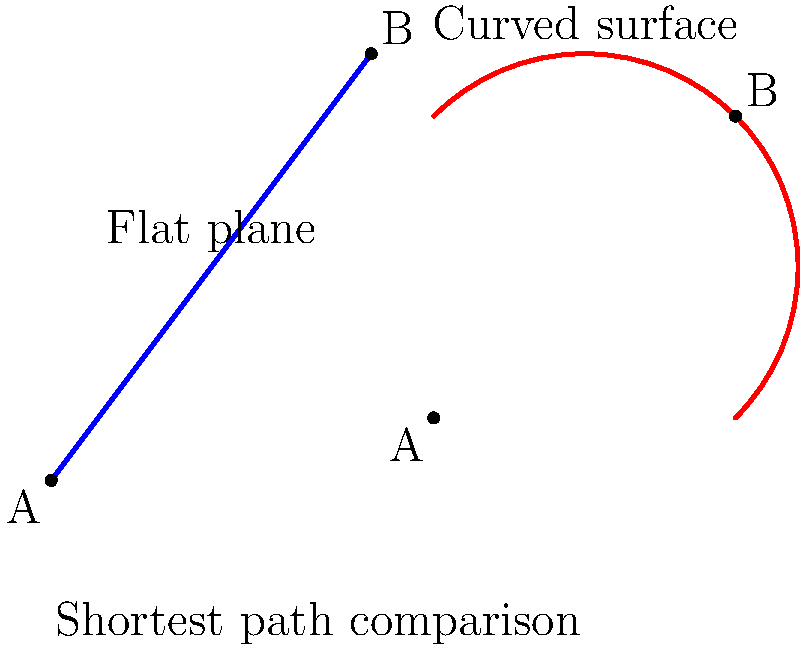Consider two points A and B on a flat plane and the same two points on a curved surface (e.g., a sphere). If the straight-line distance between A and B on the flat plane is 5 units, what can we conclude about the length of the shortest path between A and B on the curved surface?

a) It will always be equal to 5 units
b) It will always be less than 5 units
c) It will always be greater than 5 units
d) It could be equal to, less than, or greater than 5 units, depending on the specific curved surface To answer this question, let's consider the properties of Non-Euclidean Geometry and compare the shortest paths on flat and curved surfaces:

1. On a flat plane (Euclidean geometry):
   - The shortest path between two points is always a straight line.
   - In this case, the straight-line distance is given as 5 units.

2. On a curved surface (Non-Euclidean geometry):
   - The shortest path between two points is called a geodesic.
   - Geodesics on curved surfaces are not necessarily straight lines.

3. Comparing the paths:
   - On a flat plane, the shortest path is always the straight line (5 units in this case).
   - On a curved surface, the path length depends on the specific curvature:
     a) On a sphere: The geodesic is a great circle arc, which is always longer than the straight-line distance.
     b) On a hyperbolic surface: The geodesic can be shorter than the straight-line distance.
     c) On a saddle-shaped surface: The geodesic can be equal to, shorter than, or longer than the straight-line distance, depending on the specific geometry.

4. Conclusion:
   The length of the shortest path on a curved surface can vary depending on the type and degree of curvature. It's not always possible to predict whether it will be longer, shorter, or equal to the straight-line distance without knowing the specific surface properties.

Therefore, the correct answer is that the length of the shortest path on the curved surface could be equal to, less than, or greater than 5 units, depending on the specific curved surface.
Answer: d) It could be equal to, less than, or greater than 5 units, depending on the specific curved surface 